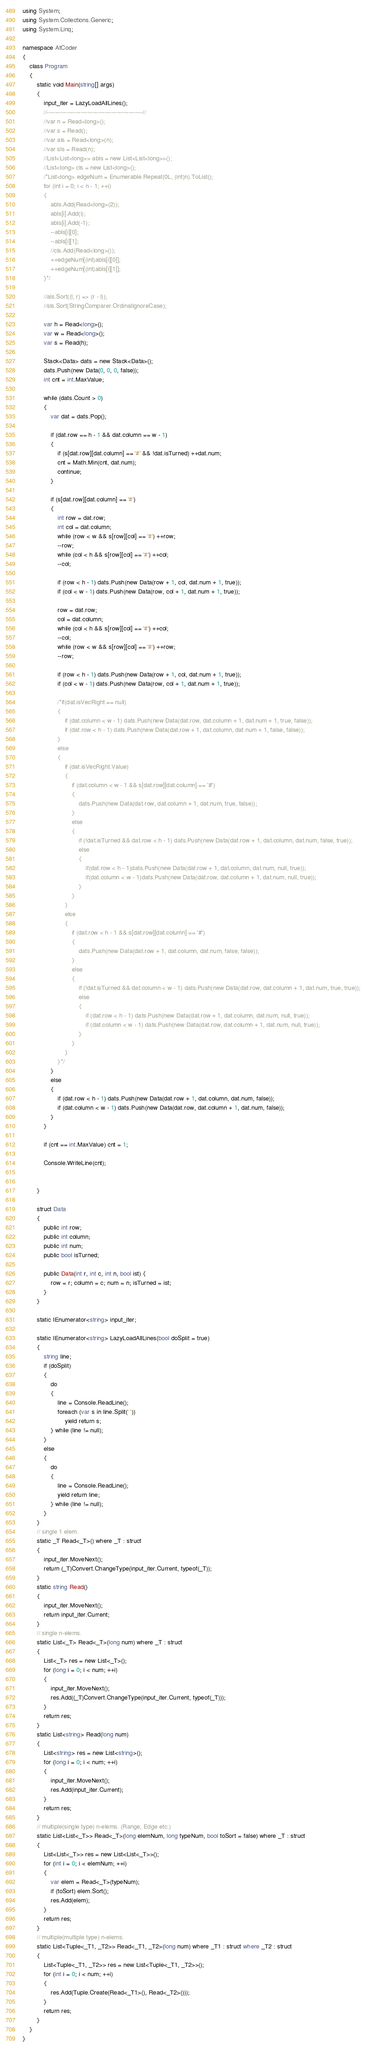Convert code to text. <code><loc_0><loc_0><loc_500><loc_500><_C#_>using System;
using System.Collections.Generic;
using System.Linq;

namespace AtCoder
{
    class Program
    {
        static void Main(string[] args)
        {
            input_iter = LazyLoadAllLines();
            //------------------------------------------------//
            //var n = Read<long>();
            //var s = Read();
            //var als = Read<long>(n);
            //var sls = Read(n);
            //List<List<long>> abls = new List<List<long>>();
            //List<long> cls = new List<long>();
            /*List<long> edgeNum = Enumerable.Repeat(0L, (int)n).ToList();
            for (int i = 0; i < n - 1; ++i)
            {
                abls.Add(Read<long>(2));
                abls[i].Add(i);
                abls[i].Add(-1);
                --abls[i][0];
                --abls[i][1];
                //cls.Add(Read<long>());
                ++edgeNum[(int)abls[i][0]];
                ++edgeNum[(int)abls[i][1]];
            }*/

            //als.Sort((l, r) => (r - l));
            //sls.Sort(StringComparer.OrdinalIgnoreCase);

            var h = Read<long>();
            var w = Read<long>();
            var s = Read(h);

            Stack<Data> dats = new Stack<Data>();
            dats.Push(new Data(0, 0, 0, false));
            int cnt = int.MaxValue;

            while (dats.Count > 0)
            {
                var dat = dats.Pop();

                if (dat.row == h - 1 && dat.column == w - 1)
                {
                    if (s[dat.row][dat.column] == '#' && !dat.isTurned) ++dat.num;
                    cnt = Math.Min(cnt, dat.num);
                    continue;
                }

                if (s[dat.row][dat.column] == '#')
                {
                    int row = dat.row;
                    int col = dat.column;
                    while (row < w && s[row][col] == '#') ++row;
                    --row;
                    while (col < h && s[row][col] == '#') ++col;
                    --col;

                    if (row < h - 1) dats.Push(new Data(row + 1, col, dat.num + 1, true));
                    if (col < w - 1) dats.Push(new Data(row, col + 1, dat.num + 1, true));

                    row = dat.row;
                    col = dat.column;
                    while (col < h && s[row][col] == '#') ++col;
                    --col;
                    while (row < w && s[row][col] == '#') ++row;
                    --row;

                    if (row < h - 1) dats.Push(new Data(row + 1, col, dat.num + 1, true));
                    if (col < w - 1) dats.Push(new Data(row, col + 1, dat.num + 1, true));

                    /*if(dat.isVecRight == null)
                    {
                        if (dat.column < w - 1) dats.Push(new Data(dat.row, dat.column + 1, dat.num + 1, true, false));
                        if (dat.row < h - 1) dats.Push(new Data(dat.row + 1, dat.column, dat.num + 1, false, false));
                    }
                    else
                    {
                        if (dat.isVecRight.Value)
                        {
                            if (dat.column < w - 1 && s[dat.row][dat.column] == '#')
                            {
                                dats.Push(new Data(dat.row, dat.column + 1, dat.num, true, false));
                            }
                            else
                            {
                                if (!dat.isTurned && dat.row < h - 1) dats.Push(new Data(dat.row + 1, dat.column, dat.num, false, true));
                                else
                                {
                                    if(dat.row < h - 1)dats.Push(new Data(dat.row + 1, dat.column, dat.num, null, true));
                                    if(dat.column < w - 1)dats.Push(new Data(dat.row, dat.column + 1, dat.num, null, true));
                                }
                            }
                        }
                        else
                        {
                            if (dat.row < h - 1 && s[dat.row][dat.column] == '#')
                            {
                                dats.Push(new Data(dat.row + 1, dat.column, dat.num, false, false));
                            }
                            else
                            {
                                if (!dat.isTurned && dat.column < w - 1) dats.Push(new Data(dat.row, dat.column + 1, dat.num, true, true));
                                else
                                {
                                    if (dat.row < h - 1) dats.Push(new Data(dat.row + 1, dat.column, dat.num, null, true));
                                    if (dat.column < w - 1) dats.Push(new Data(dat.row, dat.column + 1, dat.num, null, true));
                                }
                            }
                        }
                    }*/
                }
                else
                {
                    if (dat.row < h - 1) dats.Push(new Data(dat.row + 1, dat.column, dat.num, false));
                    if (dat.column < w - 1) dats.Push(new Data(dat.row, dat.column + 1, dat.num, false));
                }
            }

            if (cnt == int.MaxValue) cnt = 1;

            Console.WriteLine(cnt);


        }

        struct Data
        {
            public int row;
            public int column;
            public int num;
            public bool isTurned;

            public Data(int r, int c, int n, bool ist) {
                row = r; column = c; num = n; isTurned = ist;
            }
        }

        static IEnumerator<string> input_iter;

        static IEnumerator<string> LazyLoadAllLines(bool doSplit = true)
        {
            string line;
            if (doSplit)
            {
                do
                {
                    line = Console.ReadLine();
                    foreach (var s in line.Split(' '))
                        yield return s;
                } while (line != null);
            }
            else
            {
                do
                {
                    line = Console.ReadLine();
                    yield return line;
                } while (line != null);
            }
        }
        // single 1 elem.
        static _T Read<_T>() where _T : struct
        {
            input_iter.MoveNext();
            return (_T)Convert.ChangeType(input_iter.Current, typeof(_T));
        }
        static string Read()
        {
            input_iter.MoveNext();
            return input_iter.Current;
        }
        // single n-elems.
        static List<_T> Read<_T>(long num) where _T : struct
        {
            List<_T> res = new List<_T>();
            for (long i = 0; i < num; ++i)
            {
                input_iter.MoveNext();
                res.Add((_T)Convert.ChangeType(input_iter.Current, typeof(_T)));
            }
            return res;
        }
        static List<string> Read(long num)
        {
            List<string> res = new List<string>();
            for (long i = 0; i < num; ++i)
            {
                input_iter.MoveNext();
                res.Add(input_iter.Current);
            }
            return res;
        }
        // multiple(single type) n-elems. (Range, Edge etc.)
        static List<List<_T>> Read<_T>(long elemNum, long typeNum, bool toSort = false) where _T : struct
        {
            List<List<_T>> res = new List<List<_T>>();
            for (int i = 0; i < elemNum; ++i)
            {
                var elem = Read<_T>(typeNum);
                if (toSort) elem.Sort();
                res.Add(elem);
            }
            return res;
        }
        // multiple(multiple type) n-elems.
        static List<Tuple<_T1, _T2>> Read<_T1, _T2>(long num) where _T1 : struct where _T2 : struct
        {
            List<Tuple<_T1, _T2>> res = new List<Tuple<_T1, _T2>>();
            for (int i = 0; i < num; ++i)
            {
                res.Add(Tuple.Create(Read<_T1>(), Read<_T2>()));
            }
            return res;
        }
    }
}
</code> 